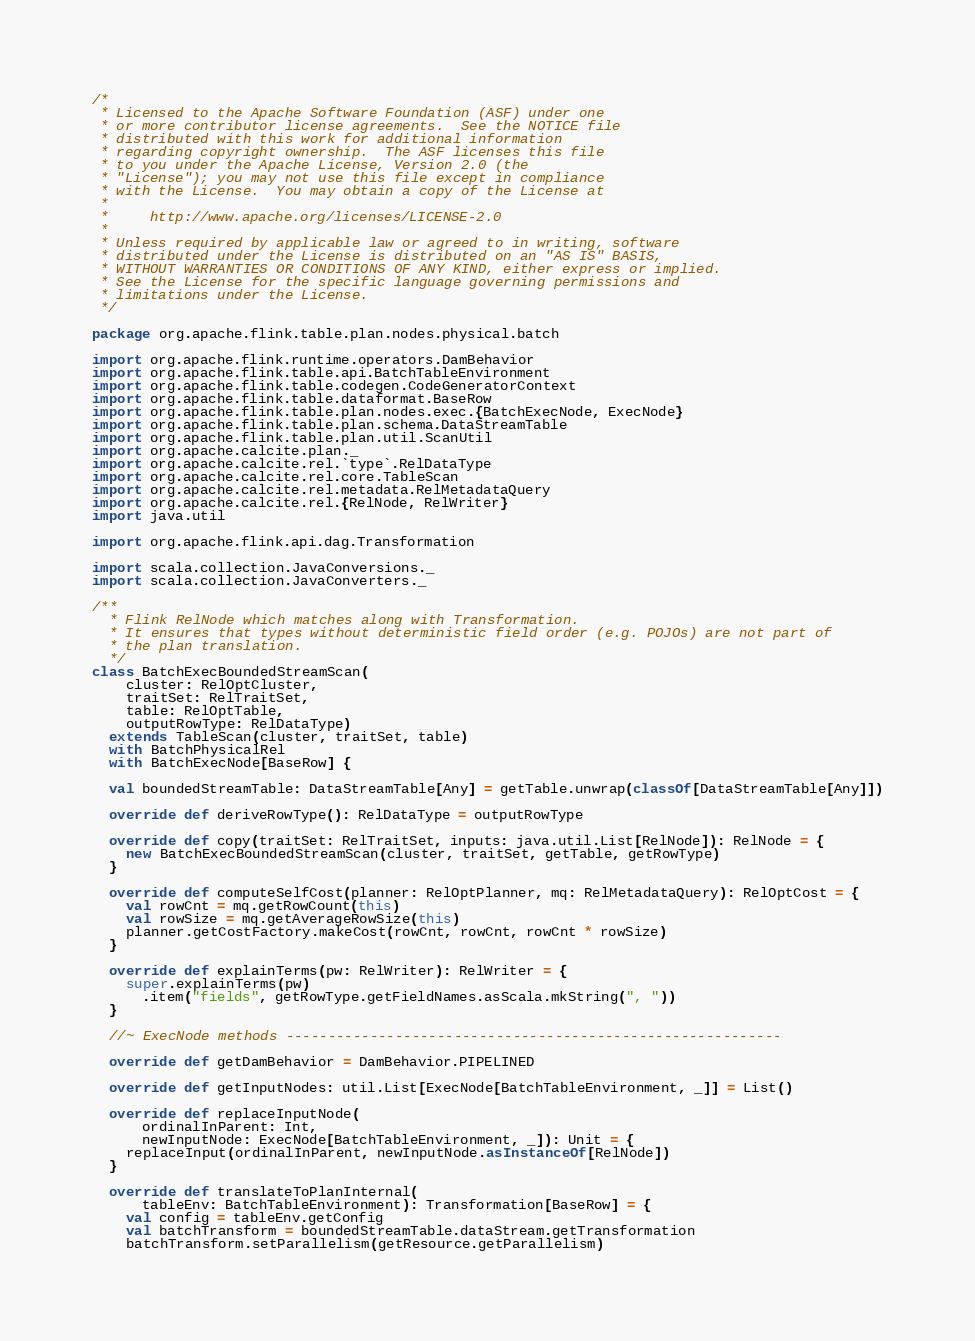Convert code to text. <code><loc_0><loc_0><loc_500><loc_500><_Scala_>/*
 * Licensed to the Apache Software Foundation (ASF) under one
 * or more contributor license agreements.  See the NOTICE file
 * distributed with this work for additional information
 * regarding copyright ownership.  The ASF licenses this file
 * to you under the Apache License, Version 2.0 (the
 * "License"); you may not use this file except in compliance
 * with the License.  You may obtain a copy of the License at
 *
 *     http://www.apache.org/licenses/LICENSE-2.0
 *
 * Unless required by applicable law or agreed to in writing, software
 * distributed under the License is distributed on an "AS IS" BASIS,
 * WITHOUT WARRANTIES OR CONDITIONS OF ANY KIND, either express or implied.
 * See the License for the specific language governing permissions and
 * limitations under the License.
 */

package org.apache.flink.table.plan.nodes.physical.batch

import org.apache.flink.runtime.operators.DamBehavior
import org.apache.flink.table.api.BatchTableEnvironment
import org.apache.flink.table.codegen.CodeGeneratorContext
import org.apache.flink.table.dataformat.BaseRow
import org.apache.flink.table.plan.nodes.exec.{BatchExecNode, ExecNode}
import org.apache.flink.table.plan.schema.DataStreamTable
import org.apache.flink.table.plan.util.ScanUtil
import org.apache.calcite.plan._
import org.apache.calcite.rel.`type`.RelDataType
import org.apache.calcite.rel.core.TableScan
import org.apache.calcite.rel.metadata.RelMetadataQuery
import org.apache.calcite.rel.{RelNode, RelWriter}
import java.util

import org.apache.flink.api.dag.Transformation

import scala.collection.JavaConversions._
import scala.collection.JavaConverters._

/**
  * Flink RelNode which matches along with Transformation.
  * It ensures that types without deterministic field order (e.g. POJOs) are not part of
  * the plan translation.
  */
class BatchExecBoundedStreamScan(
    cluster: RelOptCluster,
    traitSet: RelTraitSet,
    table: RelOptTable,
    outputRowType: RelDataType)
  extends TableScan(cluster, traitSet, table)
  with BatchPhysicalRel
  with BatchExecNode[BaseRow] {

  val boundedStreamTable: DataStreamTable[Any] = getTable.unwrap(classOf[DataStreamTable[Any]])

  override def deriveRowType(): RelDataType = outputRowType

  override def copy(traitSet: RelTraitSet, inputs: java.util.List[RelNode]): RelNode = {
    new BatchExecBoundedStreamScan(cluster, traitSet, getTable, getRowType)
  }

  override def computeSelfCost(planner: RelOptPlanner, mq: RelMetadataQuery): RelOptCost = {
    val rowCnt = mq.getRowCount(this)
    val rowSize = mq.getAverageRowSize(this)
    planner.getCostFactory.makeCost(rowCnt, rowCnt, rowCnt * rowSize)
  }

  override def explainTerms(pw: RelWriter): RelWriter = {
    super.explainTerms(pw)
      .item("fields", getRowType.getFieldNames.asScala.mkString(", "))
  }

  //~ ExecNode methods -----------------------------------------------------------

  override def getDamBehavior = DamBehavior.PIPELINED

  override def getInputNodes: util.List[ExecNode[BatchTableEnvironment, _]] = List()

  override def replaceInputNode(
      ordinalInParent: Int,
      newInputNode: ExecNode[BatchTableEnvironment, _]): Unit = {
    replaceInput(ordinalInParent, newInputNode.asInstanceOf[RelNode])
  }

  override def translateToPlanInternal(
      tableEnv: BatchTableEnvironment): Transformation[BaseRow] = {
    val config = tableEnv.getConfig
    val batchTransform = boundedStreamTable.dataStream.getTransformation
    batchTransform.setParallelism(getResource.getParallelism)</code> 